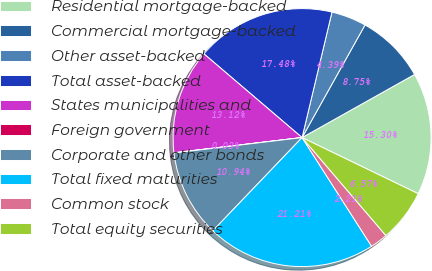Convert chart. <chart><loc_0><loc_0><loc_500><loc_500><pie_chart><fcel>Residential mortgage-backed<fcel>Commercial mortgage-backed<fcel>Other asset-backed<fcel>Total asset-backed<fcel>States municipalities and<fcel>Foreign government<fcel>Corporate and other bonds<fcel>Total fixed maturities<fcel>Common stock<fcel>Total equity securities<nl><fcel>15.3%<fcel>8.75%<fcel>4.39%<fcel>17.48%<fcel>13.12%<fcel>0.03%<fcel>10.94%<fcel>21.21%<fcel>2.21%<fcel>6.57%<nl></chart> 